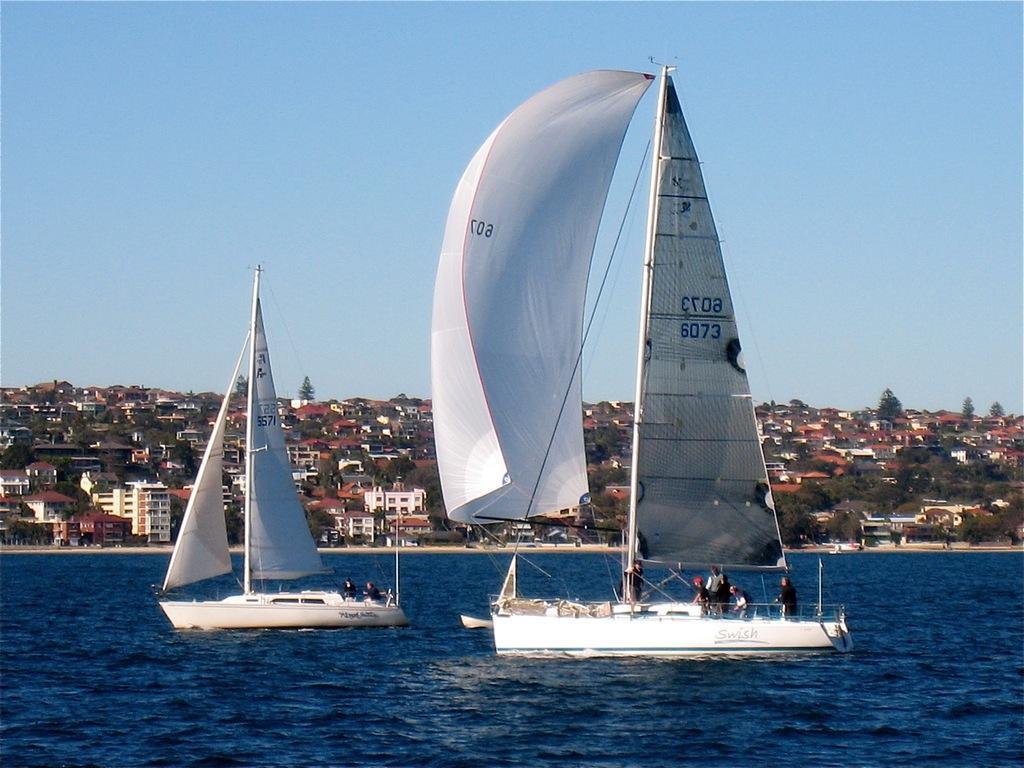Please provide a concise description of this image. In this image, we can see people on the boats. In the background, there are buildings and trees. At the top, there is sky and at the bottom, there is water. 